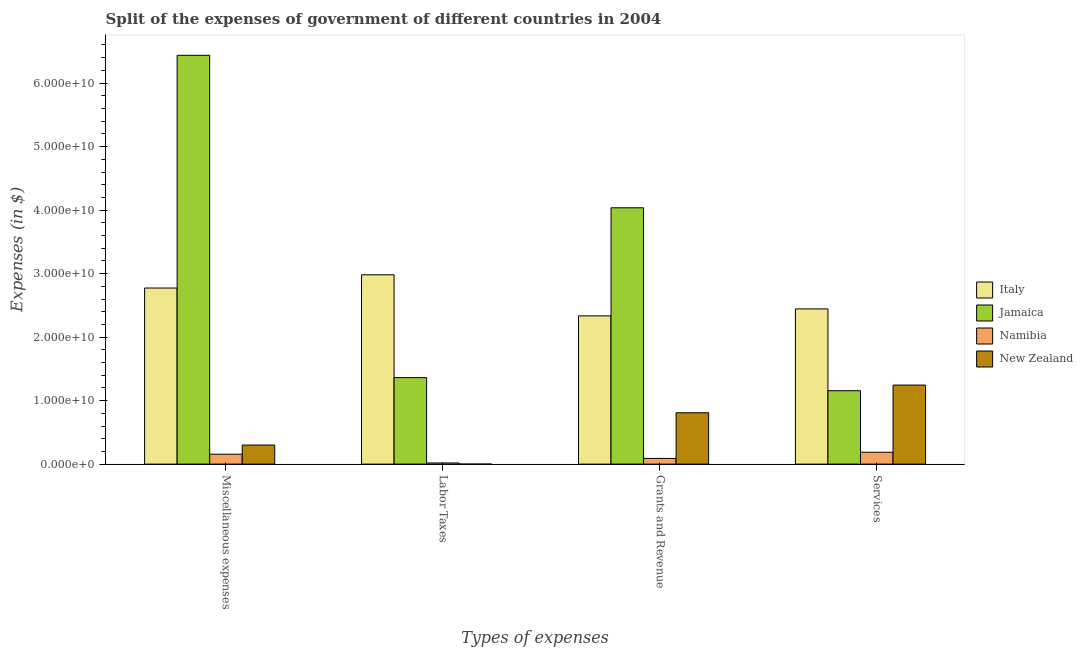How many different coloured bars are there?
Provide a short and direct response. 4. What is the label of the 1st group of bars from the left?
Your answer should be very brief. Miscellaneous expenses. What is the amount spent on labor taxes in New Zealand?
Keep it short and to the point. 2.35e+06. Across all countries, what is the maximum amount spent on services?
Ensure brevity in your answer.  2.44e+1. Across all countries, what is the minimum amount spent on miscellaneous expenses?
Give a very brief answer. 1.56e+09. In which country was the amount spent on miscellaneous expenses minimum?
Offer a terse response. Namibia. What is the total amount spent on miscellaneous expenses in the graph?
Keep it short and to the point. 9.67e+1. What is the difference between the amount spent on labor taxes in Jamaica and that in Italy?
Make the answer very short. -1.62e+1. What is the difference between the amount spent on labor taxes in Jamaica and the amount spent on services in Namibia?
Make the answer very short. 1.18e+1. What is the average amount spent on labor taxes per country?
Provide a short and direct response. 1.09e+1. What is the difference between the amount spent on grants and revenue and amount spent on miscellaneous expenses in New Zealand?
Make the answer very short. 5.08e+09. In how many countries, is the amount spent on labor taxes greater than 40000000000 $?
Keep it short and to the point. 0. What is the ratio of the amount spent on services in New Zealand to that in Jamaica?
Your response must be concise. 1.08. Is the difference between the amount spent on grants and revenue in New Zealand and Namibia greater than the difference between the amount spent on services in New Zealand and Namibia?
Provide a succinct answer. No. What is the difference between the highest and the second highest amount spent on grants and revenue?
Give a very brief answer. 1.70e+1. What is the difference between the highest and the lowest amount spent on grants and revenue?
Make the answer very short. 3.95e+1. Is the sum of the amount spent on labor taxes in New Zealand and Jamaica greater than the maximum amount spent on grants and revenue across all countries?
Offer a terse response. No. What does the 4th bar from the left in Services represents?
Offer a very short reply. New Zealand. Is it the case that in every country, the sum of the amount spent on miscellaneous expenses and amount spent on labor taxes is greater than the amount spent on grants and revenue?
Ensure brevity in your answer.  No. How many bars are there?
Make the answer very short. 16. Are all the bars in the graph horizontal?
Offer a very short reply. No. How many countries are there in the graph?
Offer a terse response. 4. Are the values on the major ticks of Y-axis written in scientific E-notation?
Give a very brief answer. Yes. Does the graph contain grids?
Provide a short and direct response. No. How many legend labels are there?
Provide a short and direct response. 4. How are the legend labels stacked?
Ensure brevity in your answer.  Vertical. What is the title of the graph?
Give a very brief answer. Split of the expenses of government of different countries in 2004. Does "Cabo Verde" appear as one of the legend labels in the graph?
Your response must be concise. No. What is the label or title of the X-axis?
Keep it short and to the point. Types of expenses. What is the label or title of the Y-axis?
Give a very brief answer. Expenses (in $). What is the Expenses (in $) of Italy in Miscellaneous expenses?
Give a very brief answer. 2.77e+1. What is the Expenses (in $) in Jamaica in Miscellaneous expenses?
Your answer should be compact. 6.44e+1. What is the Expenses (in $) in Namibia in Miscellaneous expenses?
Your answer should be very brief. 1.56e+09. What is the Expenses (in $) of New Zealand in Miscellaneous expenses?
Give a very brief answer. 3.00e+09. What is the Expenses (in $) of Italy in Labor Taxes?
Give a very brief answer. 2.98e+1. What is the Expenses (in $) of Jamaica in Labor Taxes?
Give a very brief answer. 1.36e+1. What is the Expenses (in $) of Namibia in Labor Taxes?
Your answer should be very brief. 1.80e+08. What is the Expenses (in $) of New Zealand in Labor Taxes?
Ensure brevity in your answer.  2.35e+06. What is the Expenses (in $) in Italy in Grants and Revenue?
Keep it short and to the point. 2.33e+1. What is the Expenses (in $) in Jamaica in Grants and Revenue?
Provide a short and direct response. 4.04e+1. What is the Expenses (in $) in Namibia in Grants and Revenue?
Provide a succinct answer. 8.97e+08. What is the Expenses (in $) of New Zealand in Grants and Revenue?
Offer a very short reply. 8.09e+09. What is the Expenses (in $) in Italy in Services?
Your answer should be very brief. 2.44e+1. What is the Expenses (in $) in Jamaica in Services?
Your answer should be compact. 1.16e+1. What is the Expenses (in $) in Namibia in Services?
Provide a short and direct response. 1.87e+09. What is the Expenses (in $) in New Zealand in Services?
Make the answer very short. 1.24e+1. Across all Types of expenses, what is the maximum Expenses (in $) in Italy?
Provide a succinct answer. 2.98e+1. Across all Types of expenses, what is the maximum Expenses (in $) of Jamaica?
Your answer should be compact. 6.44e+1. Across all Types of expenses, what is the maximum Expenses (in $) in Namibia?
Make the answer very short. 1.87e+09. Across all Types of expenses, what is the maximum Expenses (in $) in New Zealand?
Offer a very short reply. 1.24e+1. Across all Types of expenses, what is the minimum Expenses (in $) in Italy?
Your answer should be compact. 2.33e+1. Across all Types of expenses, what is the minimum Expenses (in $) in Jamaica?
Your response must be concise. 1.16e+1. Across all Types of expenses, what is the minimum Expenses (in $) of Namibia?
Give a very brief answer. 1.80e+08. Across all Types of expenses, what is the minimum Expenses (in $) of New Zealand?
Provide a succinct answer. 2.35e+06. What is the total Expenses (in $) of Italy in the graph?
Your answer should be compact. 1.05e+11. What is the total Expenses (in $) in Jamaica in the graph?
Your response must be concise. 1.30e+11. What is the total Expenses (in $) of Namibia in the graph?
Give a very brief answer. 4.51e+09. What is the total Expenses (in $) of New Zealand in the graph?
Provide a succinct answer. 2.35e+1. What is the difference between the Expenses (in $) of Italy in Miscellaneous expenses and that in Labor Taxes?
Keep it short and to the point. -2.08e+09. What is the difference between the Expenses (in $) in Jamaica in Miscellaneous expenses and that in Labor Taxes?
Your answer should be compact. 5.08e+1. What is the difference between the Expenses (in $) in Namibia in Miscellaneous expenses and that in Labor Taxes?
Ensure brevity in your answer.  1.38e+09. What is the difference between the Expenses (in $) in New Zealand in Miscellaneous expenses and that in Labor Taxes?
Provide a succinct answer. 3.00e+09. What is the difference between the Expenses (in $) in Italy in Miscellaneous expenses and that in Grants and Revenue?
Your answer should be very brief. 4.39e+09. What is the difference between the Expenses (in $) of Jamaica in Miscellaneous expenses and that in Grants and Revenue?
Ensure brevity in your answer.  2.40e+1. What is the difference between the Expenses (in $) in Namibia in Miscellaneous expenses and that in Grants and Revenue?
Give a very brief answer. 6.65e+08. What is the difference between the Expenses (in $) of New Zealand in Miscellaneous expenses and that in Grants and Revenue?
Offer a terse response. -5.08e+09. What is the difference between the Expenses (in $) in Italy in Miscellaneous expenses and that in Services?
Make the answer very short. 3.29e+09. What is the difference between the Expenses (in $) in Jamaica in Miscellaneous expenses and that in Services?
Your answer should be compact. 5.28e+1. What is the difference between the Expenses (in $) of Namibia in Miscellaneous expenses and that in Services?
Your response must be concise. -3.09e+08. What is the difference between the Expenses (in $) in New Zealand in Miscellaneous expenses and that in Services?
Your answer should be very brief. -9.44e+09. What is the difference between the Expenses (in $) in Italy in Labor Taxes and that in Grants and Revenue?
Your response must be concise. 6.47e+09. What is the difference between the Expenses (in $) of Jamaica in Labor Taxes and that in Grants and Revenue?
Offer a terse response. -2.67e+1. What is the difference between the Expenses (in $) of Namibia in Labor Taxes and that in Grants and Revenue?
Make the answer very short. -7.17e+08. What is the difference between the Expenses (in $) of New Zealand in Labor Taxes and that in Grants and Revenue?
Ensure brevity in your answer.  -8.08e+09. What is the difference between the Expenses (in $) in Italy in Labor Taxes and that in Services?
Provide a succinct answer. 5.38e+09. What is the difference between the Expenses (in $) of Jamaica in Labor Taxes and that in Services?
Make the answer very short. 2.06e+09. What is the difference between the Expenses (in $) of Namibia in Labor Taxes and that in Services?
Offer a very short reply. -1.69e+09. What is the difference between the Expenses (in $) of New Zealand in Labor Taxes and that in Services?
Your answer should be very brief. -1.24e+1. What is the difference between the Expenses (in $) in Italy in Grants and Revenue and that in Services?
Your response must be concise. -1.10e+09. What is the difference between the Expenses (in $) in Jamaica in Grants and Revenue and that in Services?
Offer a terse response. 2.88e+1. What is the difference between the Expenses (in $) of Namibia in Grants and Revenue and that in Services?
Give a very brief answer. -9.74e+08. What is the difference between the Expenses (in $) in New Zealand in Grants and Revenue and that in Services?
Your answer should be very brief. -4.36e+09. What is the difference between the Expenses (in $) of Italy in Miscellaneous expenses and the Expenses (in $) of Jamaica in Labor Taxes?
Ensure brevity in your answer.  1.41e+1. What is the difference between the Expenses (in $) in Italy in Miscellaneous expenses and the Expenses (in $) in Namibia in Labor Taxes?
Make the answer very short. 2.76e+1. What is the difference between the Expenses (in $) of Italy in Miscellaneous expenses and the Expenses (in $) of New Zealand in Labor Taxes?
Ensure brevity in your answer.  2.77e+1. What is the difference between the Expenses (in $) in Jamaica in Miscellaneous expenses and the Expenses (in $) in Namibia in Labor Taxes?
Provide a short and direct response. 6.42e+1. What is the difference between the Expenses (in $) in Jamaica in Miscellaneous expenses and the Expenses (in $) in New Zealand in Labor Taxes?
Offer a terse response. 6.44e+1. What is the difference between the Expenses (in $) of Namibia in Miscellaneous expenses and the Expenses (in $) of New Zealand in Labor Taxes?
Keep it short and to the point. 1.56e+09. What is the difference between the Expenses (in $) of Italy in Miscellaneous expenses and the Expenses (in $) of Jamaica in Grants and Revenue?
Your answer should be very brief. -1.26e+1. What is the difference between the Expenses (in $) of Italy in Miscellaneous expenses and the Expenses (in $) of Namibia in Grants and Revenue?
Provide a succinct answer. 2.68e+1. What is the difference between the Expenses (in $) of Italy in Miscellaneous expenses and the Expenses (in $) of New Zealand in Grants and Revenue?
Provide a succinct answer. 1.96e+1. What is the difference between the Expenses (in $) in Jamaica in Miscellaneous expenses and the Expenses (in $) in Namibia in Grants and Revenue?
Give a very brief answer. 6.35e+1. What is the difference between the Expenses (in $) of Jamaica in Miscellaneous expenses and the Expenses (in $) of New Zealand in Grants and Revenue?
Provide a short and direct response. 5.63e+1. What is the difference between the Expenses (in $) of Namibia in Miscellaneous expenses and the Expenses (in $) of New Zealand in Grants and Revenue?
Your answer should be very brief. -6.52e+09. What is the difference between the Expenses (in $) in Italy in Miscellaneous expenses and the Expenses (in $) in Jamaica in Services?
Your answer should be compact. 1.62e+1. What is the difference between the Expenses (in $) in Italy in Miscellaneous expenses and the Expenses (in $) in Namibia in Services?
Keep it short and to the point. 2.59e+1. What is the difference between the Expenses (in $) in Italy in Miscellaneous expenses and the Expenses (in $) in New Zealand in Services?
Your answer should be very brief. 1.53e+1. What is the difference between the Expenses (in $) of Jamaica in Miscellaneous expenses and the Expenses (in $) of Namibia in Services?
Offer a terse response. 6.25e+1. What is the difference between the Expenses (in $) of Jamaica in Miscellaneous expenses and the Expenses (in $) of New Zealand in Services?
Your response must be concise. 5.19e+1. What is the difference between the Expenses (in $) in Namibia in Miscellaneous expenses and the Expenses (in $) in New Zealand in Services?
Give a very brief answer. -1.09e+1. What is the difference between the Expenses (in $) of Italy in Labor Taxes and the Expenses (in $) of Jamaica in Grants and Revenue?
Provide a short and direct response. -1.05e+1. What is the difference between the Expenses (in $) in Italy in Labor Taxes and the Expenses (in $) in Namibia in Grants and Revenue?
Provide a succinct answer. 2.89e+1. What is the difference between the Expenses (in $) in Italy in Labor Taxes and the Expenses (in $) in New Zealand in Grants and Revenue?
Keep it short and to the point. 2.17e+1. What is the difference between the Expenses (in $) of Jamaica in Labor Taxes and the Expenses (in $) of Namibia in Grants and Revenue?
Keep it short and to the point. 1.27e+1. What is the difference between the Expenses (in $) of Jamaica in Labor Taxes and the Expenses (in $) of New Zealand in Grants and Revenue?
Your answer should be compact. 5.54e+09. What is the difference between the Expenses (in $) in Namibia in Labor Taxes and the Expenses (in $) in New Zealand in Grants and Revenue?
Ensure brevity in your answer.  -7.91e+09. What is the difference between the Expenses (in $) in Italy in Labor Taxes and the Expenses (in $) in Jamaica in Services?
Give a very brief answer. 1.83e+1. What is the difference between the Expenses (in $) of Italy in Labor Taxes and the Expenses (in $) of Namibia in Services?
Give a very brief answer. 2.79e+1. What is the difference between the Expenses (in $) in Italy in Labor Taxes and the Expenses (in $) in New Zealand in Services?
Make the answer very short. 1.74e+1. What is the difference between the Expenses (in $) in Jamaica in Labor Taxes and the Expenses (in $) in Namibia in Services?
Make the answer very short. 1.18e+1. What is the difference between the Expenses (in $) of Jamaica in Labor Taxes and the Expenses (in $) of New Zealand in Services?
Your answer should be compact. 1.18e+09. What is the difference between the Expenses (in $) of Namibia in Labor Taxes and the Expenses (in $) of New Zealand in Services?
Your response must be concise. -1.23e+1. What is the difference between the Expenses (in $) of Italy in Grants and Revenue and the Expenses (in $) of Jamaica in Services?
Keep it short and to the point. 1.18e+1. What is the difference between the Expenses (in $) in Italy in Grants and Revenue and the Expenses (in $) in Namibia in Services?
Offer a terse response. 2.15e+1. What is the difference between the Expenses (in $) of Italy in Grants and Revenue and the Expenses (in $) of New Zealand in Services?
Give a very brief answer. 1.09e+1. What is the difference between the Expenses (in $) in Jamaica in Grants and Revenue and the Expenses (in $) in Namibia in Services?
Your answer should be compact. 3.85e+1. What is the difference between the Expenses (in $) of Jamaica in Grants and Revenue and the Expenses (in $) of New Zealand in Services?
Your response must be concise. 2.79e+1. What is the difference between the Expenses (in $) of Namibia in Grants and Revenue and the Expenses (in $) of New Zealand in Services?
Your answer should be very brief. -1.16e+1. What is the average Expenses (in $) of Italy per Types of expenses?
Your response must be concise. 2.63e+1. What is the average Expenses (in $) in Jamaica per Types of expenses?
Your response must be concise. 3.25e+1. What is the average Expenses (in $) of Namibia per Types of expenses?
Keep it short and to the point. 1.13e+09. What is the average Expenses (in $) of New Zealand per Types of expenses?
Your answer should be very brief. 5.89e+09. What is the difference between the Expenses (in $) in Italy and Expenses (in $) in Jamaica in Miscellaneous expenses?
Your answer should be very brief. -3.66e+1. What is the difference between the Expenses (in $) in Italy and Expenses (in $) in Namibia in Miscellaneous expenses?
Keep it short and to the point. 2.62e+1. What is the difference between the Expenses (in $) in Italy and Expenses (in $) in New Zealand in Miscellaneous expenses?
Make the answer very short. 2.47e+1. What is the difference between the Expenses (in $) of Jamaica and Expenses (in $) of Namibia in Miscellaneous expenses?
Give a very brief answer. 6.28e+1. What is the difference between the Expenses (in $) in Jamaica and Expenses (in $) in New Zealand in Miscellaneous expenses?
Your response must be concise. 6.14e+1. What is the difference between the Expenses (in $) of Namibia and Expenses (in $) of New Zealand in Miscellaneous expenses?
Provide a short and direct response. -1.44e+09. What is the difference between the Expenses (in $) in Italy and Expenses (in $) in Jamaica in Labor Taxes?
Make the answer very short. 1.62e+1. What is the difference between the Expenses (in $) of Italy and Expenses (in $) of Namibia in Labor Taxes?
Your answer should be very brief. 2.96e+1. What is the difference between the Expenses (in $) of Italy and Expenses (in $) of New Zealand in Labor Taxes?
Your answer should be very brief. 2.98e+1. What is the difference between the Expenses (in $) in Jamaica and Expenses (in $) in Namibia in Labor Taxes?
Offer a very short reply. 1.34e+1. What is the difference between the Expenses (in $) in Jamaica and Expenses (in $) in New Zealand in Labor Taxes?
Offer a very short reply. 1.36e+1. What is the difference between the Expenses (in $) of Namibia and Expenses (in $) of New Zealand in Labor Taxes?
Make the answer very short. 1.78e+08. What is the difference between the Expenses (in $) in Italy and Expenses (in $) in Jamaica in Grants and Revenue?
Give a very brief answer. -1.70e+1. What is the difference between the Expenses (in $) in Italy and Expenses (in $) in Namibia in Grants and Revenue?
Make the answer very short. 2.24e+1. What is the difference between the Expenses (in $) in Italy and Expenses (in $) in New Zealand in Grants and Revenue?
Offer a very short reply. 1.53e+1. What is the difference between the Expenses (in $) in Jamaica and Expenses (in $) in Namibia in Grants and Revenue?
Ensure brevity in your answer.  3.95e+1. What is the difference between the Expenses (in $) in Jamaica and Expenses (in $) in New Zealand in Grants and Revenue?
Your answer should be compact. 3.23e+1. What is the difference between the Expenses (in $) of Namibia and Expenses (in $) of New Zealand in Grants and Revenue?
Make the answer very short. -7.19e+09. What is the difference between the Expenses (in $) of Italy and Expenses (in $) of Jamaica in Services?
Provide a short and direct response. 1.29e+1. What is the difference between the Expenses (in $) in Italy and Expenses (in $) in Namibia in Services?
Offer a very short reply. 2.26e+1. What is the difference between the Expenses (in $) of Italy and Expenses (in $) of New Zealand in Services?
Your response must be concise. 1.20e+1. What is the difference between the Expenses (in $) in Jamaica and Expenses (in $) in Namibia in Services?
Make the answer very short. 9.69e+09. What is the difference between the Expenses (in $) of Jamaica and Expenses (in $) of New Zealand in Services?
Your response must be concise. -8.88e+08. What is the difference between the Expenses (in $) in Namibia and Expenses (in $) in New Zealand in Services?
Your response must be concise. -1.06e+1. What is the ratio of the Expenses (in $) in Italy in Miscellaneous expenses to that in Labor Taxes?
Make the answer very short. 0.93. What is the ratio of the Expenses (in $) in Jamaica in Miscellaneous expenses to that in Labor Taxes?
Give a very brief answer. 4.73. What is the ratio of the Expenses (in $) in Namibia in Miscellaneous expenses to that in Labor Taxes?
Offer a very short reply. 8.68. What is the ratio of the Expenses (in $) of New Zealand in Miscellaneous expenses to that in Labor Taxes?
Provide a succinct answer. 1278.51. What is the ratio of the Expenses (in $) of Italy in Miscellaneous expenses to that in Grants and Revenue?
Your answer should be compact. 1.19. What is the ratio of the Expenses (in $) of Jamaica in Miscellaneous expenses to that in Grants and Revenue?
Your answer should be very brief. 1.59. What is the ratio of the Expenses (in $) of Namibia in Miscellaneous expenses to that in Grants and Revenue?
Give a very brief answer. 1.74. What is the ratio of the Expenses (in $) in New Zealand in Miscellaneous expenses to that in Grants and Revenue?
Keep it short and to the point. 0.37. What is the ratio of the Expenses (in $) in Italy in Miscellaneous expenses to that in Services?
Make the answer very short. 1.13. What is the ratio of the Expenses (in $) in Jamaica in Miscellaneous expenses to that in Services?
Give a very brief answer. 5.57. What is the ratio of the Expenses (in $) of Namibia in Miscellaneous expenses to that in Services?
Provide a succinct answer. 0.83. What is the ratio of the Expenses (in $) of New Zealand in Miscellaneous expenses to that in Services?
Offer a very short reply. 0.24. What is the ratio of the Expenses (in $) in Italy in Labor Taxes to that in Grants and Revenue?
Keep it short and to the point. 1.28. What is the ratio of the Expenses (in $) of Jamaica in Labor Taxes to that in Grants and Revenue?
Keep it short and to the point. 0.34. What is the ratio of the Expenses (in $) of Namibia in Labor Taxes to that in Grants and Revenue?
Offer a terse response. 0.2. What is the ratio of the Expenses (in $) in Italy in Labor Taxes to that in Services?
Your answer should be compact. 1.22. What is the ratio of the Expenses (in $) of Jamaica in Labor Taxes to that in Services?
Offer a terse response. 1.18. What is the ratio of the Expenses (in $) of Namibia in Labor Taxes to that in Services?
Ensure brevity in your answer.  0.1. What is the ratio of the Expenses (in $) of New Zealand in Labor Taxes to that in Services?
Ensure brevity in your answer.  0. What is the ratio of the Expenses (in $) of Italy in Grants and Revenue to that in Services?
Provide a succinct answer. 0.96. What is the ratio of the Expenses (in $) of Jamaica in Grants and Revenue to that in Services?
Your answer should be very brief. 3.49. What is the ratio of the Expenses (in $) in Namibia in Grants and Revenue to that in Services?
Provide a short and direct response. 0.48. What is the ratio of the Expenses (in $) of New Zealand in Grants and Revenue to that in Services?
Provide a succinct answer. 0.65. What is the difference between the highest and the second highest Expenses (in $) in Italy?
Your answer should be very brief. 2.08e+09. What is the difference between the highest and the second highest Expenses (in $) in Jamaica?
Give a very brief answer. 2.40e+1. What is the difference between the highest and the second highest Expenses (in $) in Namibia?
Keep it short and to the point. 3.09e+08. What is the difference between the highest and the second highest Expenses (in $) in New Zealand?
Give a very brief answer. 4.36e+09. What is the difference between the highest and the lowest Expenses (in $) of Italy?
Provide a succinct answer. 6.47e+09. What is the difference between the highest and the lowest Expenses (in $) in Jamaica?
Your answer should be very brief. 5.28e+1. What is the difference between the highest and the lowest Expenses (in $) in Namibia?
Make the answer very short. 1.69e+09. What is the difference between the highest and the lowest Expenses (in $) in New Zealand?
Make the answer very short. 1.24e+1. 